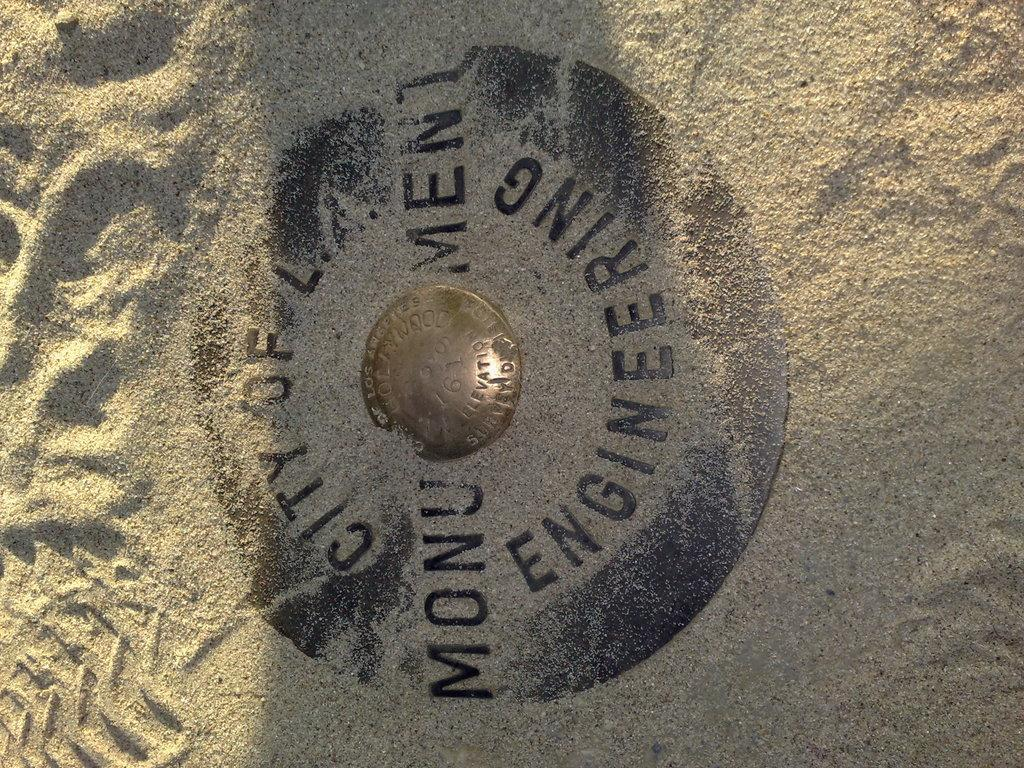<image>
Relay a brief, clear account of the picture shown. An indentation in the sand where a round ring sits with the words engineering at the bottom and says monument across the center. 